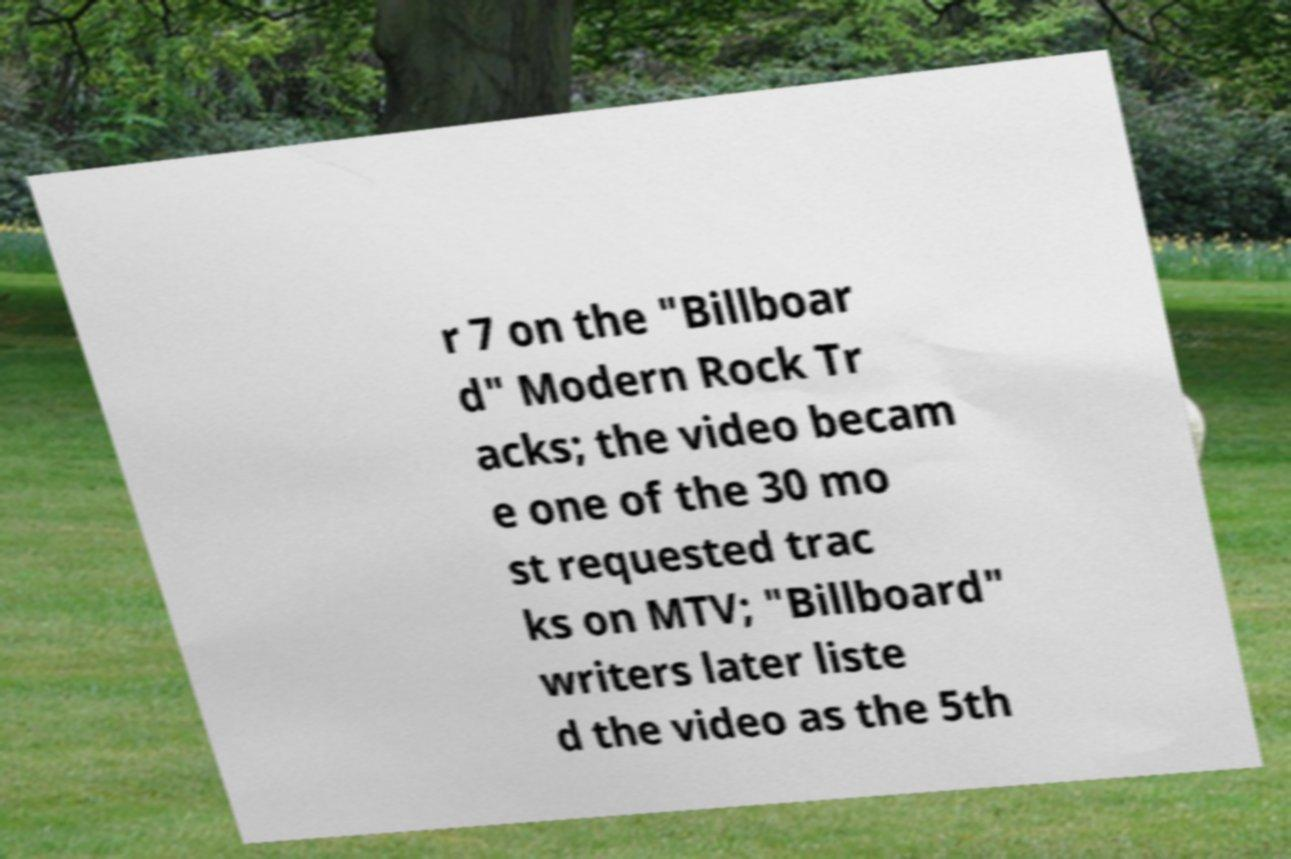For documentation purposes, I need the text within this image transcribed. Could you provide that? r 7 on the "Billboar d" Modern Rock Tr acks; the video becam e one of the 30 mo st requested trac ks on MTV; "Billboard" writers later liste d the video as the 5th 